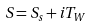Convert formula to latex. <formula><loc_0><loc_0><loc_500><loc_500>S = S _ { s } + i T _ { W }</formula> 